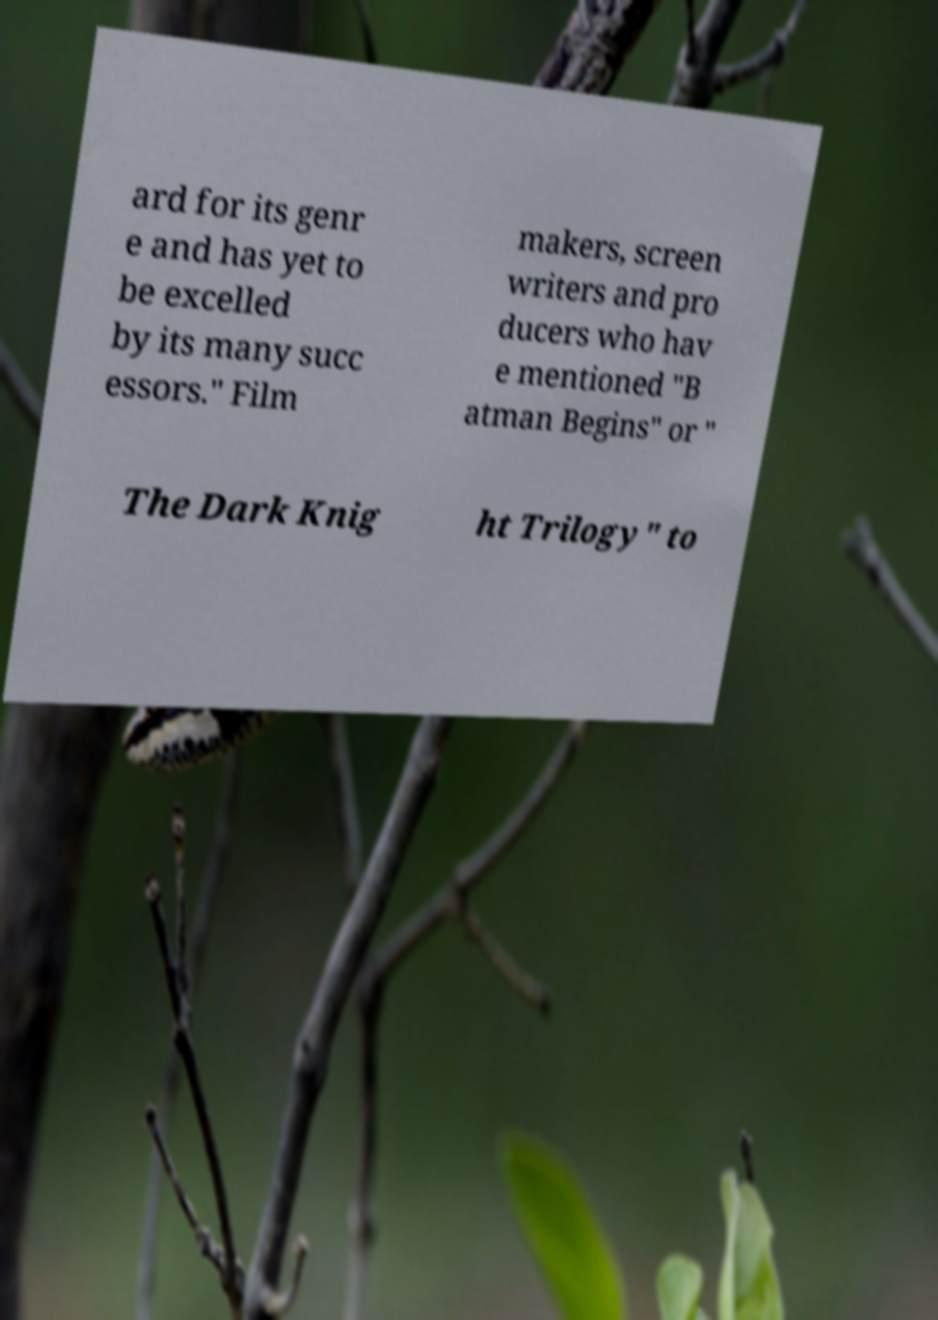Could you assist in decoding the text presented in this image and type it out clearly? ard for its genr e and has yet to be excelled by its many succ essors." Film makers, screen writers and pro ducers who hav e mentioned "B atman Begins" or " The Dark Knig ht Trilogy" to 